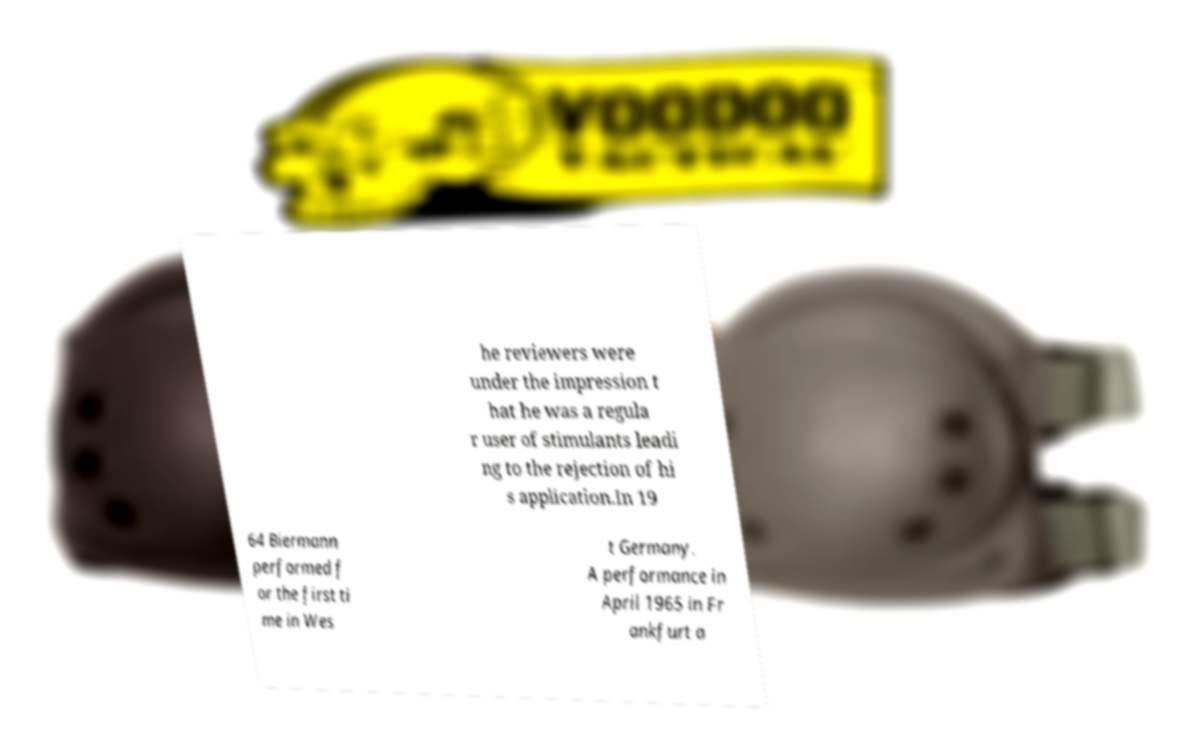Can you read and provide the text displayed in the image?This photo seems to have some interesting text. Can you extract and type it out for me? he reviewers were under the impression t hat he was a regula r user of stimulants leadi ng to the rejection of hi s application.In 19 64 Biermann performed f or the first ti me in Wes t Germany. A performance in April 1965 in Fr ankfurt a 